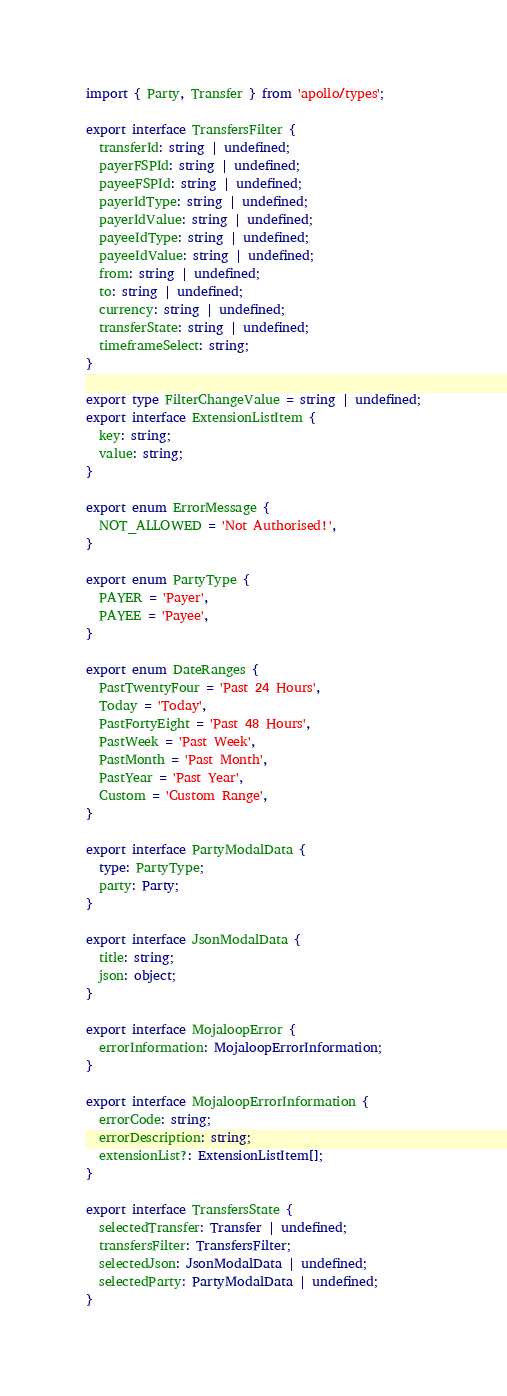Convert code to text. <code><loc_0><loc_0><loc_500><loc_500><_TypeScript_>import { Party, Transfer } from 'apollo/types';

export interface TransfersFilter {
  transferId: string | undefined;
  payerFSPId: string | undefined;
  payeeFSPId: string | undefined;
  payerIdType: string | undefined;
  payerIdValue: string | undefined;
  payeeIdType: string | undefined;
  payeeIdValue: string | undefined;
  from: string | undefined;
  to: string | undefined;
  currency: string | undefined;
  transferState: string | undefined;
  timeframeSelect: string;
}

export type FilterChangeValue = string | undefined;
export interface ExtensionListItem {
  key: string;
  value: string;
}

export enum ErrorMessage {
  NOT_ALLOWED = 'Not Authorised!',
}

export enum PartyType {
  PAYER = 'Payer',
  PAYEE = 'Payee',
}

export enum DateRanges {
  PastTwentyFour = 'Past 24 Hours',
  Today = 'Today',
  PastFortyEight = 'Past 48 Hours',
  PastWeek = 'Past Week',
  PastMonth = 'Past Month',
  PastYear = 'Past Year',
  Custom = 'Custom Range',
}

export interface PartyModalData {
  type: PartyType;
  party: Party;
}

export interface JsonModalData {
  title: string;
  json: object;
}

export interface MojaloopError {
  errorInformation: MojaloopErrorInformation;
}

export interface MojaloopErrorInformation {
  errorCode: string;
  errorDescription: string;
  extensionList?: ExtensionListItem[];
}

export interface TransfersState {
  selectedTransfer: Transfer | undefined;
  transfersFilter: TransfersFilter;
  selectedJson: JsonModalData | undefined;
  selectedParty: PartyModalData | undefined;
}
</code> 